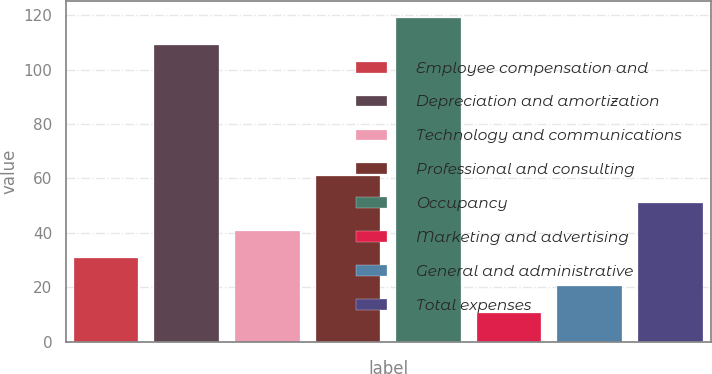Convert chart. <chart><loc_0><loc_0><loc_500><loc_500><bar_chart><fcel>Employee compensation and<fcel>Depreciation and amortization<fcel>Technology and communications<fcel>Professional and consulting<fcel>Occupancy<fcel>Marketing and advertising<fcel>General and administrative<fcel>Total expenses<nl><fcel>30.62<fcel>109<fcel>40.73<fcel>60.95<fcel>119.11<fcel>10.4<fcel>20.51<fcel>50.84<nl></chart> 